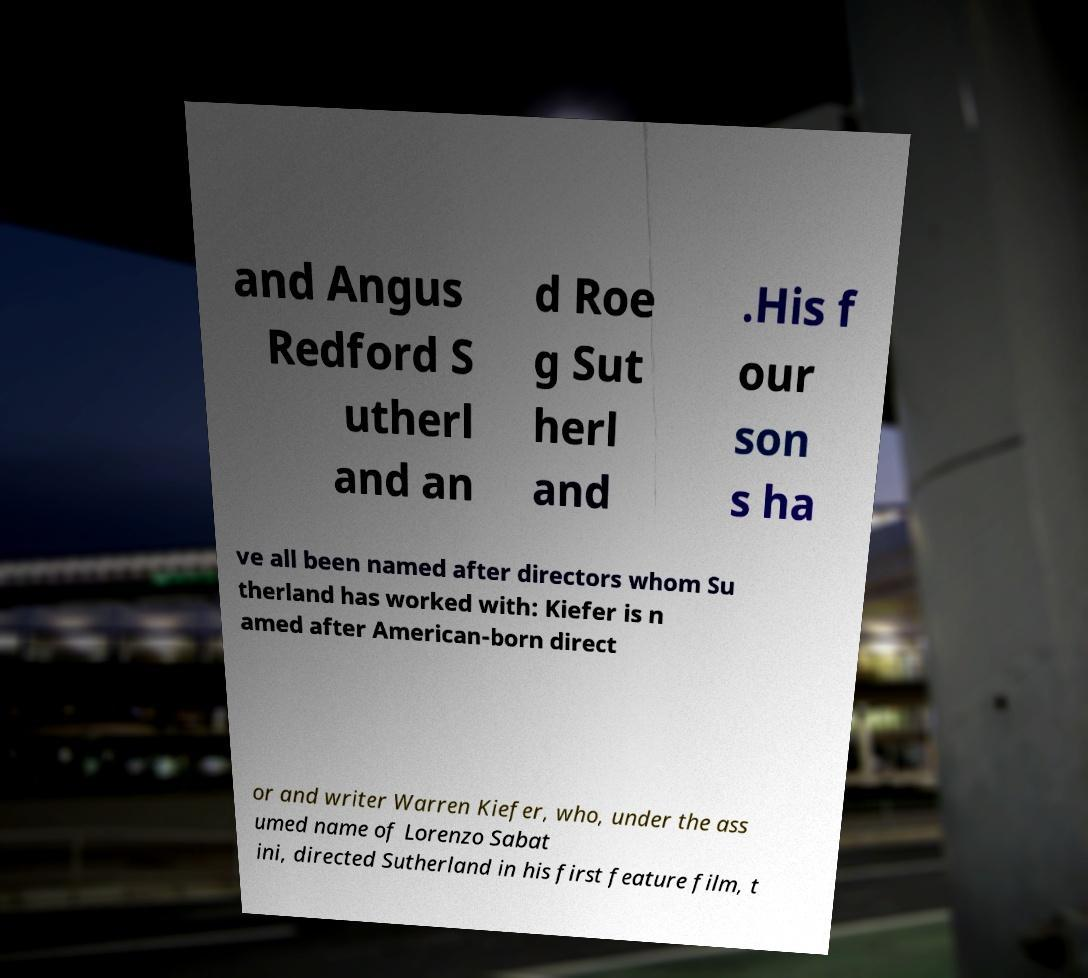What messages or text are displayed in this image? I need them in a readable, typed format. and Angus Redford S utherl and an d Roe g Sut herl and .His f our son s ha ve all been named after directors whom Su therland has worked with: Kiefer is n amed after American-born direct or and writer Warren Kiefer, who, under the ass umed name of Lorenzo Sabat ini, directed Sutherland in his first feature film, t 